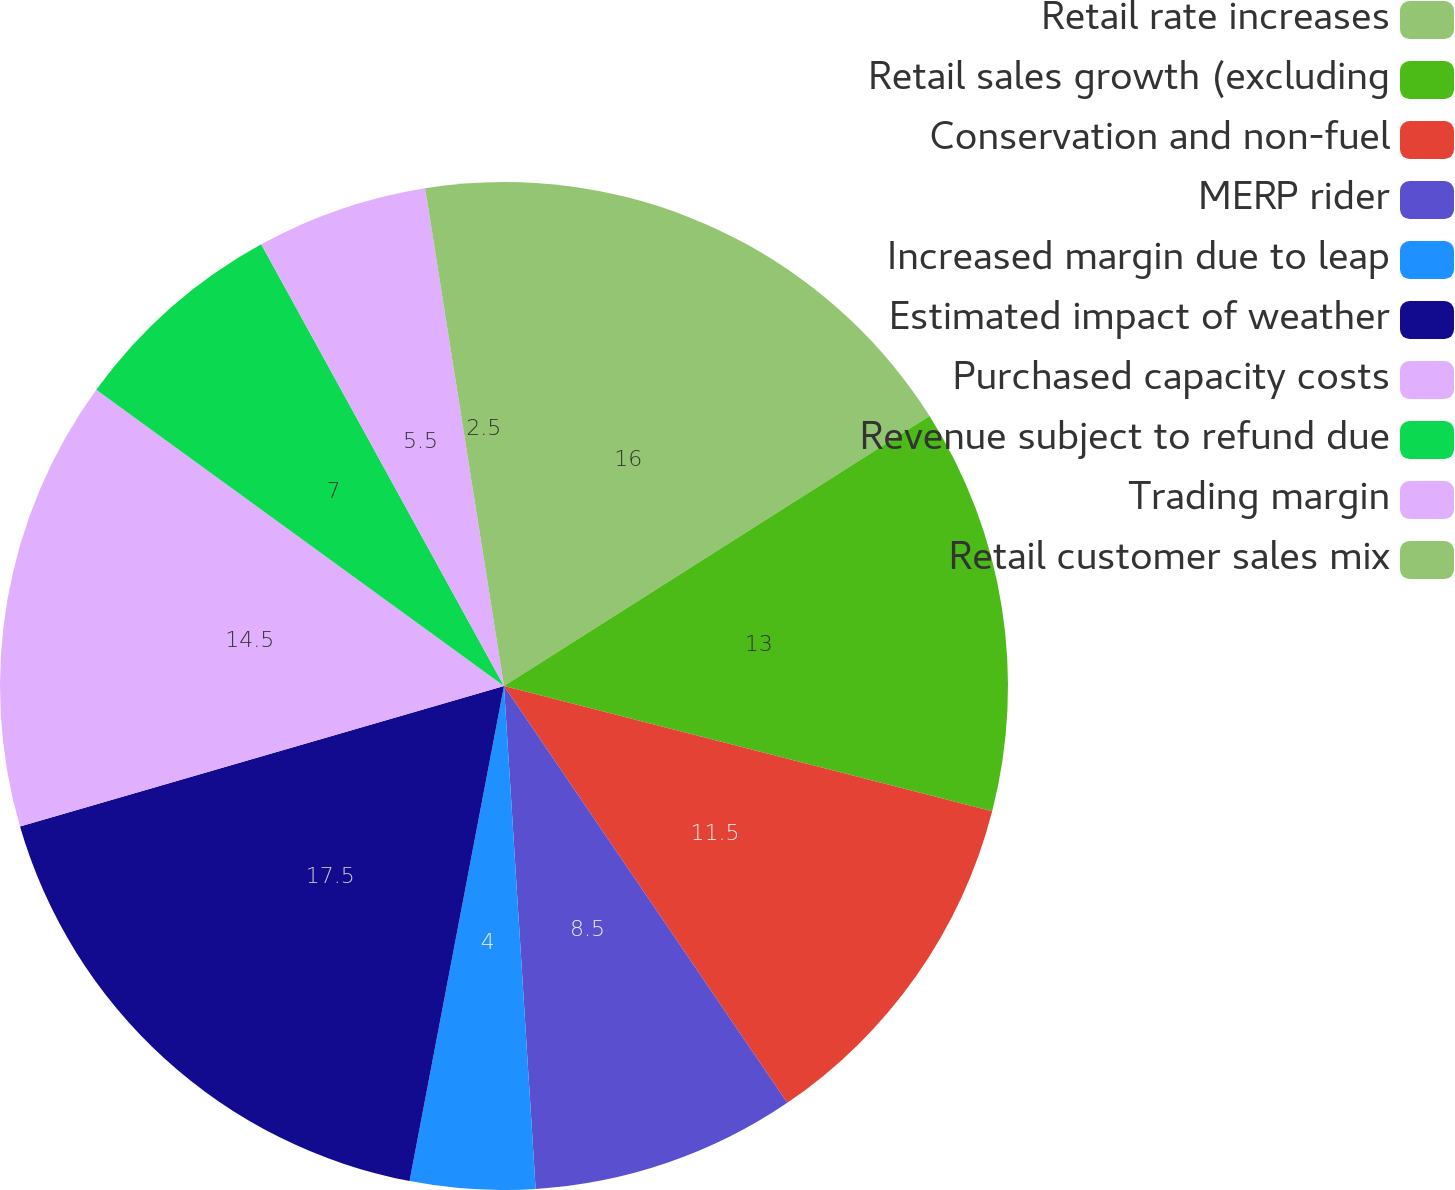Convert chart. <chart><loc_0><loc_0><loc_500><loc_500><pie_chart><fcel>Retail rate increases<fcel>Retail sales growth (excluding<fcel>Conservation and non-fuel<fcel>MERP rider<fcel>Increased margin due to leap<fcel>Estimated impact of weather<fcel>Purchased capacity costs<fcel>Revenue subject to refund due<fcel>Trading margin<fcel>Retail customer sales mix<nl><fcel>16.0%<fcel>13.0%<fcel>11.5%<fcel>8.5%<fcel>4.0%<fcel>17.5%<fcel>14.5%<fcel>7.0%<fcel>5.5%<fcel>2.5%<nl></chart> 